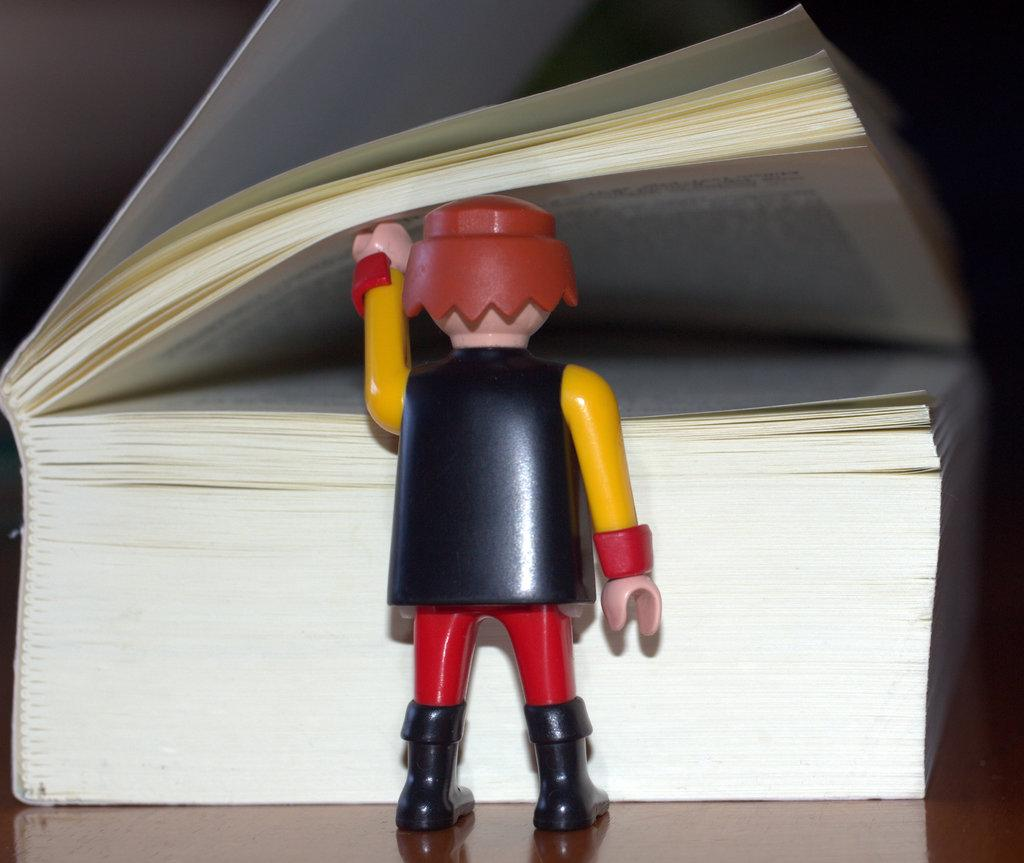What type of object can be seen in the image? There is a toy in the image. What else is present in the image besides the toy? There is a book in the image. What is the topic of the discussion taking place in the image? There is no discussion taking place in the image; it only shows a toy and a book. What is the mass of the toy in the image? The mass of the toy cannot be determined from the image alone, as it does not provide any information about the toy's weight or size. 